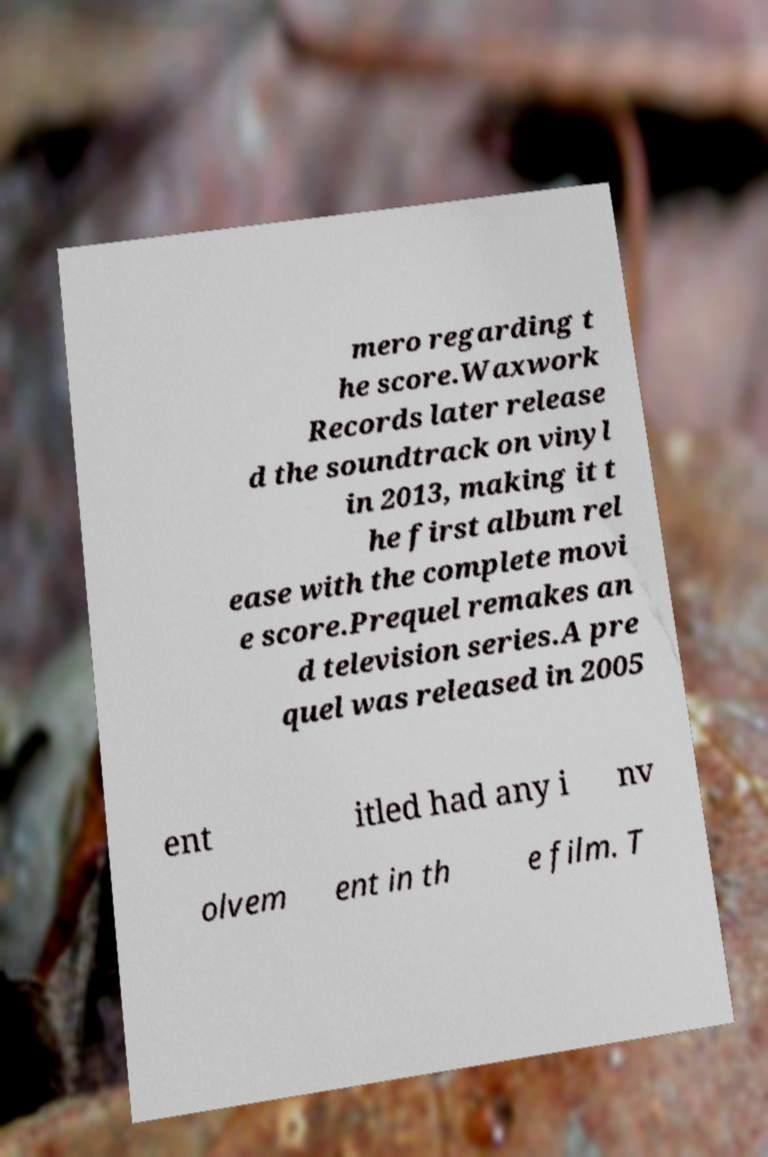Can you accurately transcribe the text from the provided image for me? mero regarding t he score.Waxwork Records later release d the soundtrack on vinyl in 2013, making it t he first album rel ease with the complete movi e score.Prequel remakes an d television series.A pre quel was released in 2005 ent itled had any i nv olvem ent in th e film. T 